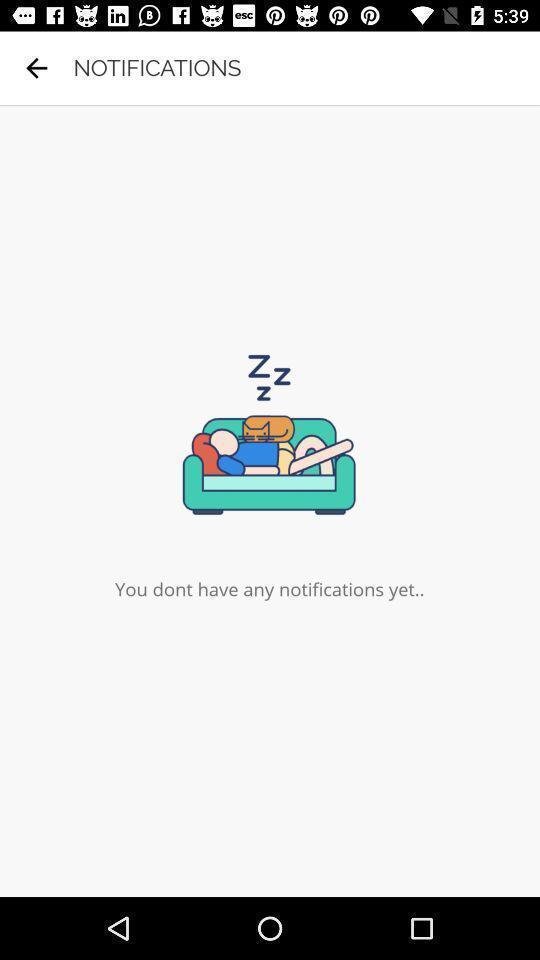Describe the visual elements of this screenshot. Page showing status on your notifications. 